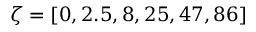Convert formula to latex. <formula><loc_0><loc_0><loc_500><loc_500>\zeta = [ 0 , 2 . 5 , 8 , 2 5 , 4 7 , 8 6 ]</formula> 